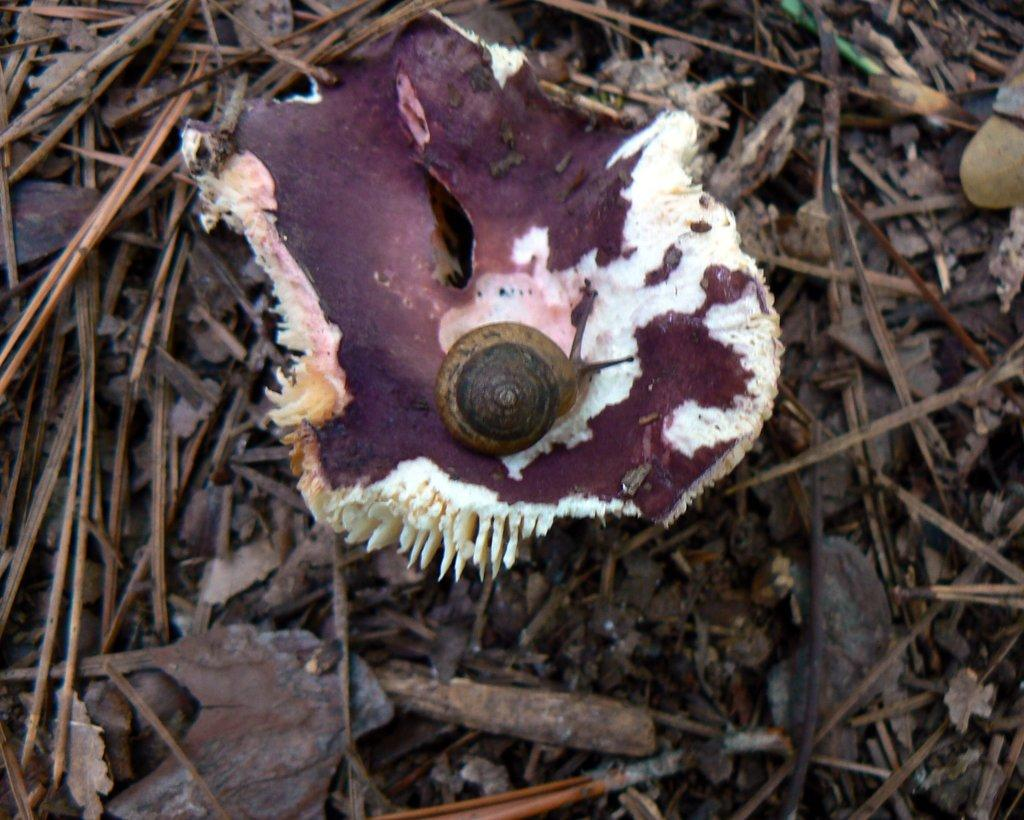What type of animal is in the image? There is a snail in the image. Where is the snail located? The snail is on an object or surface. What is the object or surface made of? The object or surface is on wooden pieces. What type of wool is the snail using to balance itself on the card? There is no wool or card present in the image, and the snail does not need to balance itself on any object. 